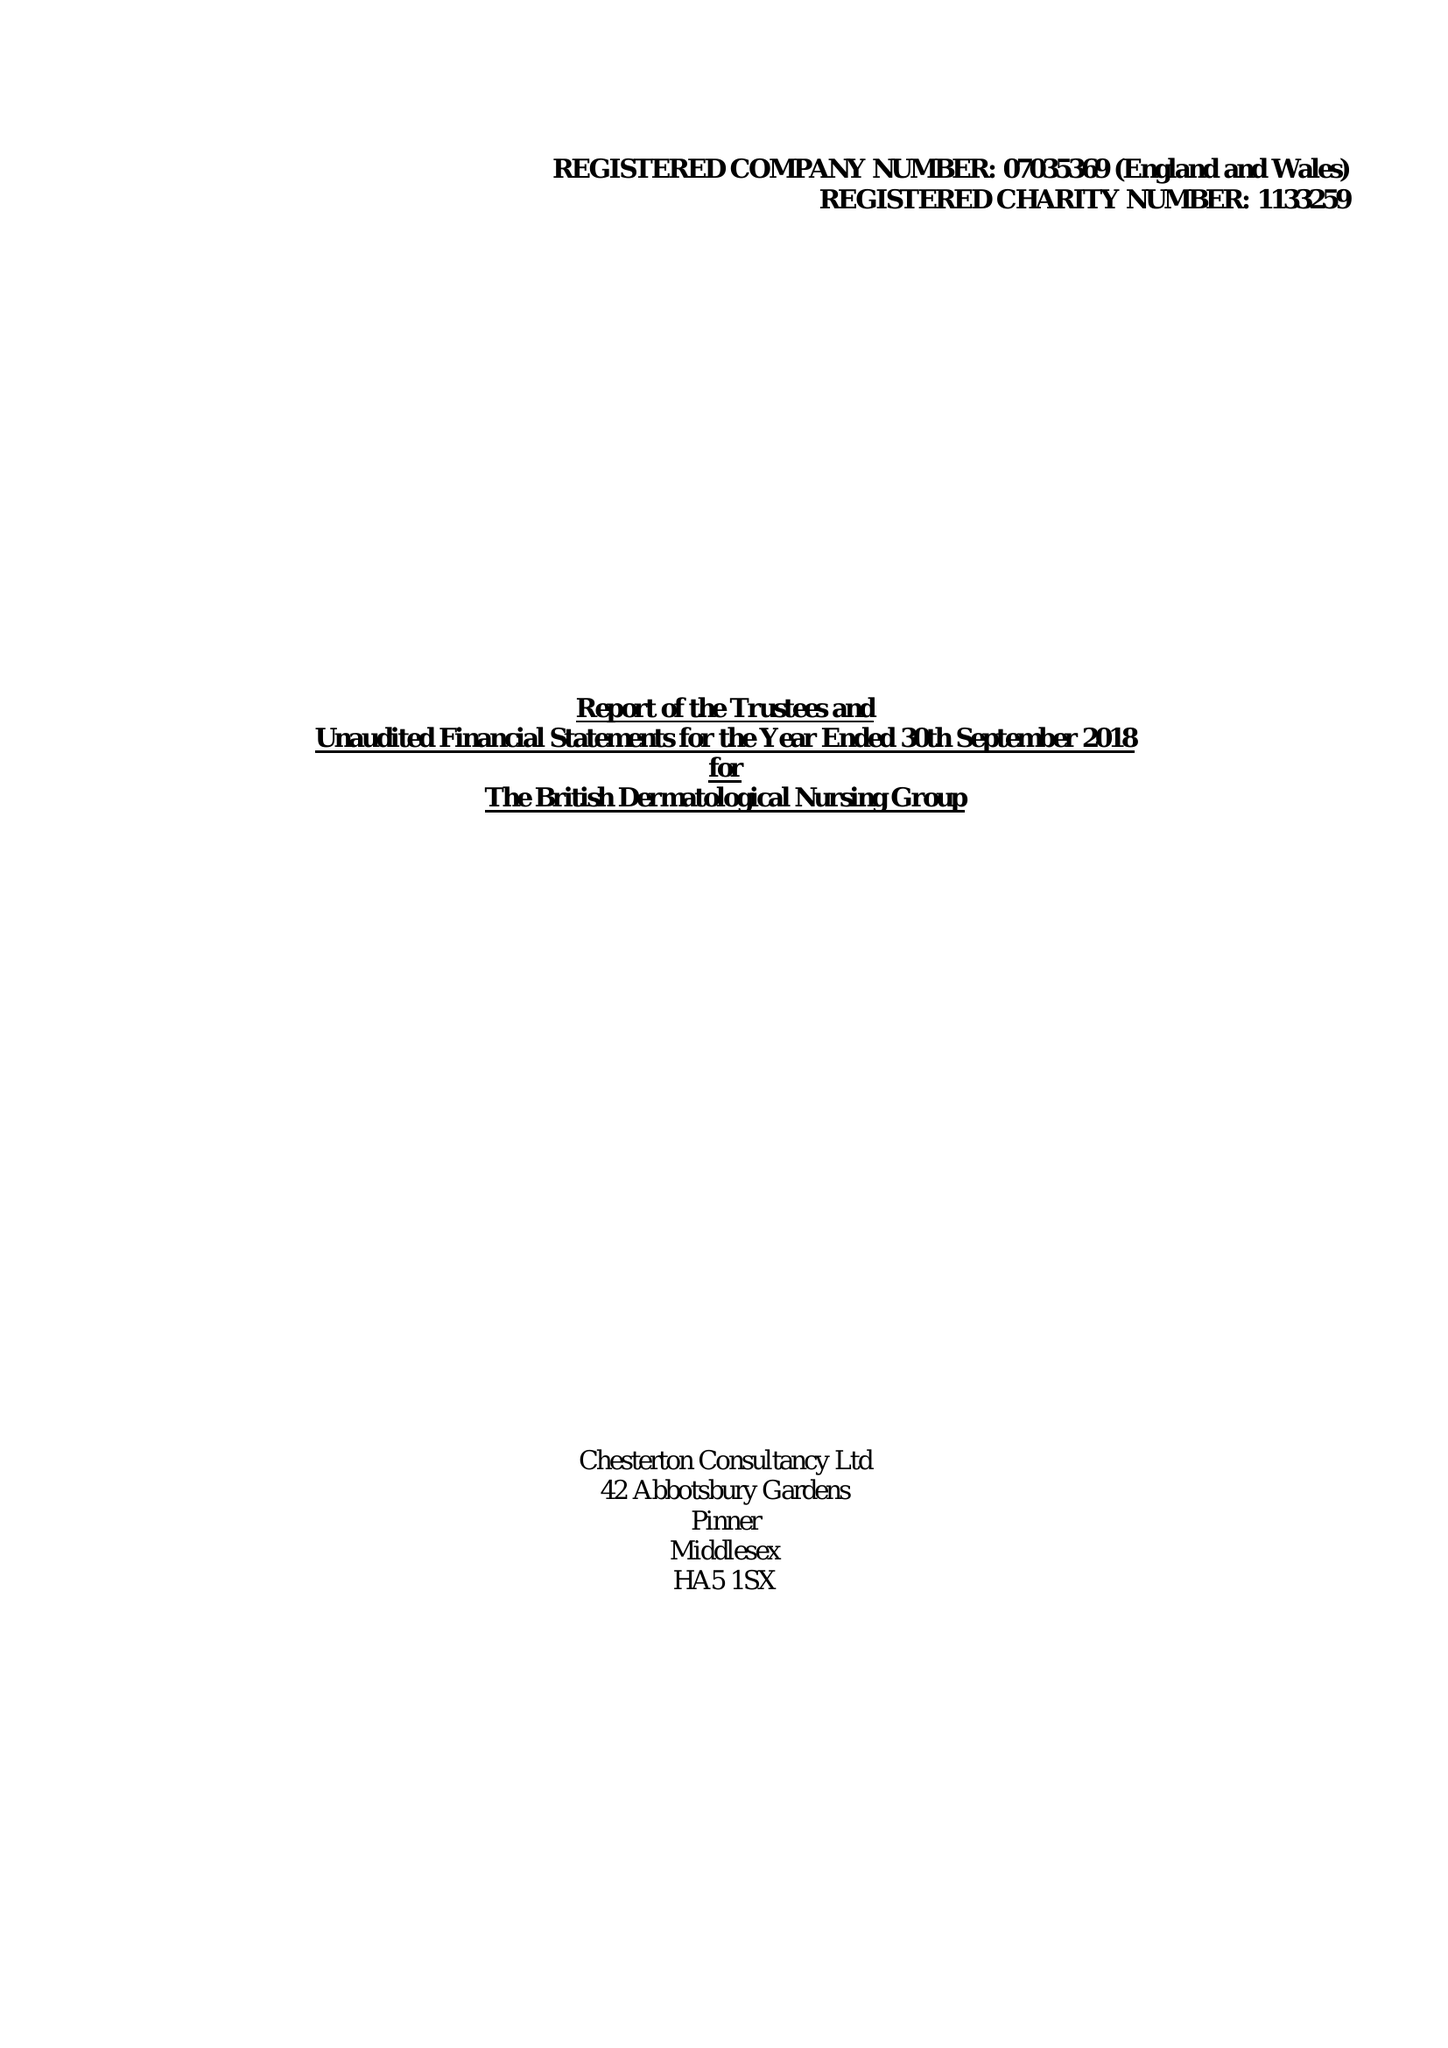What is the value for the charity_name?
Answer the question using a single word or phrase. The British Dermatological Nursing Group 